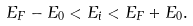Convert formula to latex. <formula><loc_0><loc_0><loc_500><loc_500>E _ { F } - E _ { 0 } < E _ { i } < E _ { F } + E _ { 0 } .</formula> 